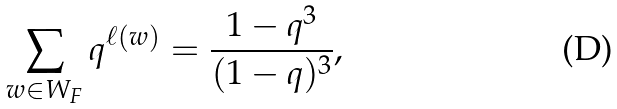<formula> <loc_0><loc_0><loc_500><loc_500>\sum _ { w \in W _ { F } } q ^ { \ell ( w ) } = \frac { 1 - q ^ { 3 } } { ( 1 - q ) ^ { 3 } } ,</formula> 